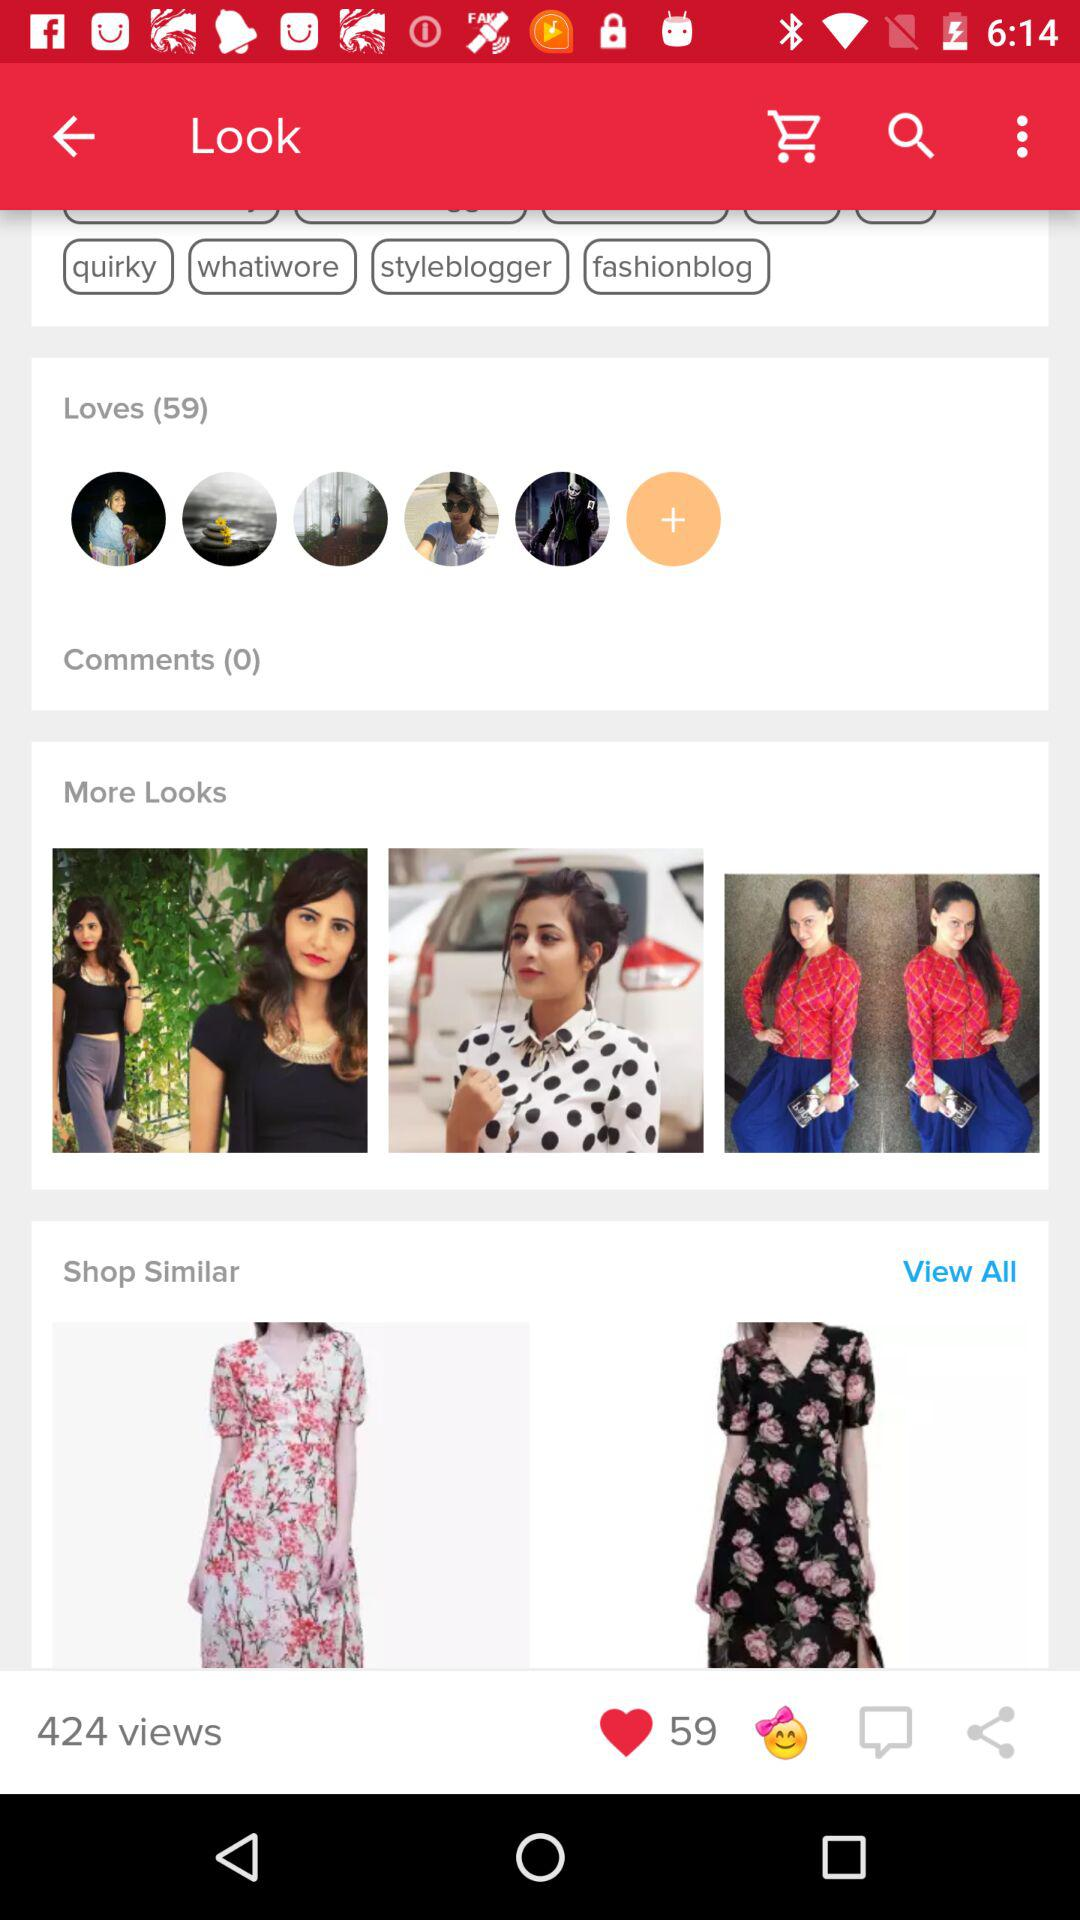How many people like it? The people who like it are 59. 